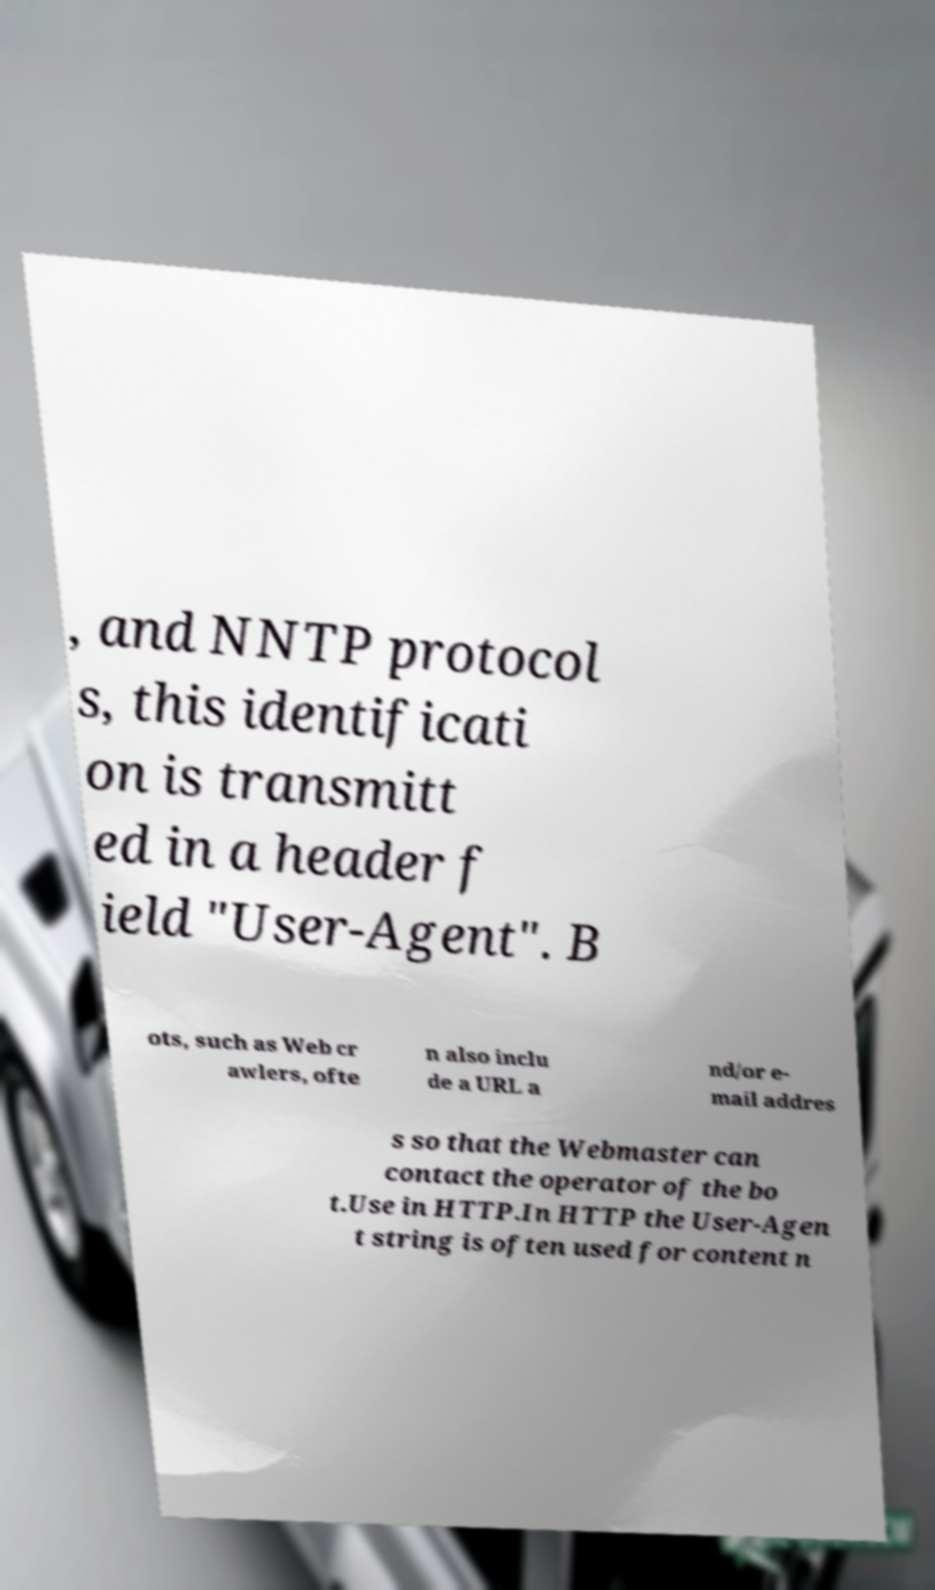There's text embedded in this image that I need extracted. Can you transcribe it verbatim? , and NNTP protocol s, this identificati on is transmitt ed in a header f ield "User-Agent". B ots, such as Web cr awlers, ofte n also inclu de a URL a nd/or e- mail addres s so that the Webmaster can contact the operator of the bo t.Use in HTTP.In HTTP the User-Agen t string is often used for content n 